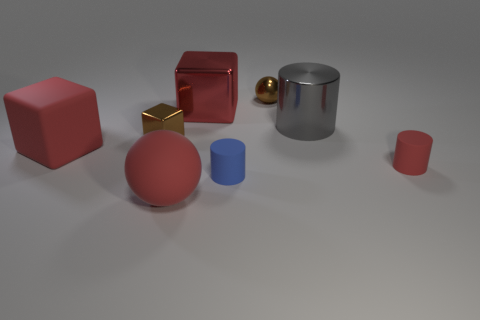The gray object has what size?
Your answer should be compact. Large. Do the large cylinder and the tiny cube have the same material?
Your answer should be very brief. Yes. How many cylinders are small metallic things or big rubber objects?
Offer a terse response. 0. What color is the small object behind the big red object behind the tiny brown shiny cube?
Give a very brief answer. Brown. What is the size of the matte block that is the same color as the rubber sphere?
Provide a succinct answer. Large. What number of brown shiny cubes are behind the brown shiny object to the left of the sphere right of the rubber sphere?
Make the answer very short. 0. Is the shape of the small brown object that is to the left of the matte sphere the same as the big shiny thing on the left side of the big gray object?
Offer a very short reply. Yes. How many objects are either blue matte cylinders or tiny rubber things?
Provide a succinct answer. 2. What is the material of the large red thing in front of the big red rubber object behind the large red matte sphere?
Your response must be concise. Rubber. Is there a small thing that has the same color as the large rubber sphere?
Offer a terse response. Yes. 